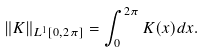Convert formula to latex. <formula><loc_0><loc_0><loc_500><loc_500>\| K \| _ { L ^ { 1 } [ 0 , 2 \pi ] } = \int _ { 0 } ^ { 2 \pi } { K ( x ) d x } .</formula> 